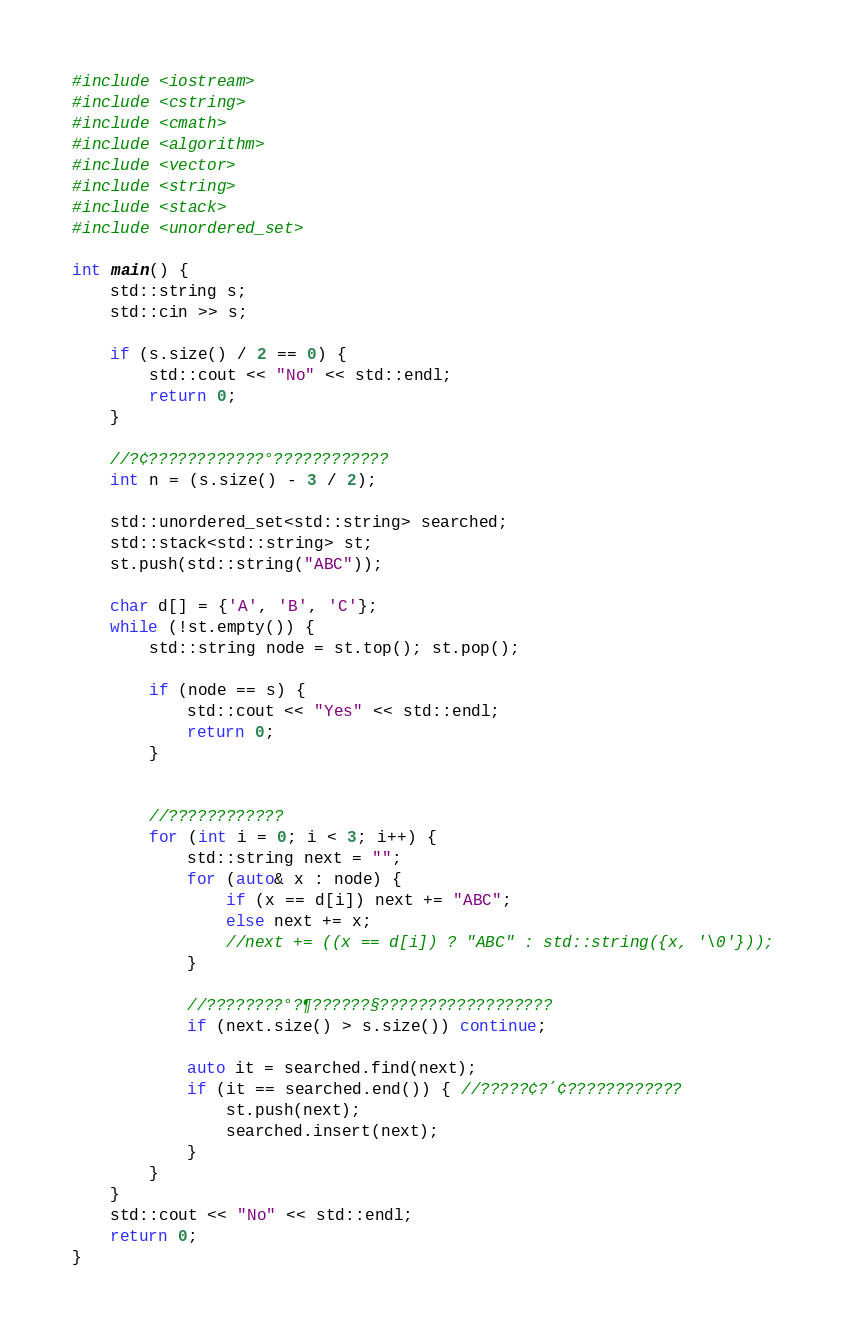<code> <loc_0><loc_0><loc_500><loc_500><_C++_>#include <iostream>
#include <cstring>
#include <cmath>
#include <algorithm>
#include <vector>
#include <string>
#include <stack>
#include <unordered_set>

int main() {
	std::string s;
	std::cin >> s;

	if (s.size() / 2 == 0) {
		std::cout << "No" << std::endl;
		return 0;
	}

	//?¢????????????°????????????
	int n = (s.size() - 3 / 2);
	
	std::unordered_set<std::string> searched;
	std::stack<std::string> st;
	st.push(std::string("ABC"));

	char d[] = {'A', 'B', 'C'};
	while (!st.empty()) {
		std::string node = st.top(); st.pop();

		if (node == s) {
			std::cout << "Yes" << std::endl;
			return 0;
		}


		//????????????
		for (int i = 0; i < 3; i++) {
			std::string next = "";
			for (auto& x : node) {
				if (x == d[i]) next += "ABC";
				else next += x;
				//next += ((x == d[i]) ? "ABC" : std::string({x, '\0'}));
			}

			//????????°?¶??????§??????????????????
			if (next.size() > s.size()) continue;

			auto it = searched.find(next);
			if (it == searched.end()) { //?????¢?´¢????????????
				st.push(next);
				searched.insert(next);
			}
		}
	}
	std::cout << "No" << std::endl;
	return 0;
}</code> 